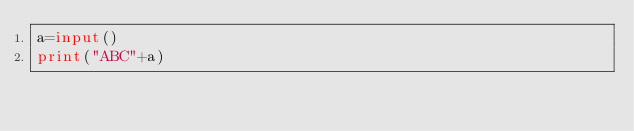<code> <loc_0><loc_0><loc_500><loc_500><_Python_>a=input()
print("ABC"+a)</code> 